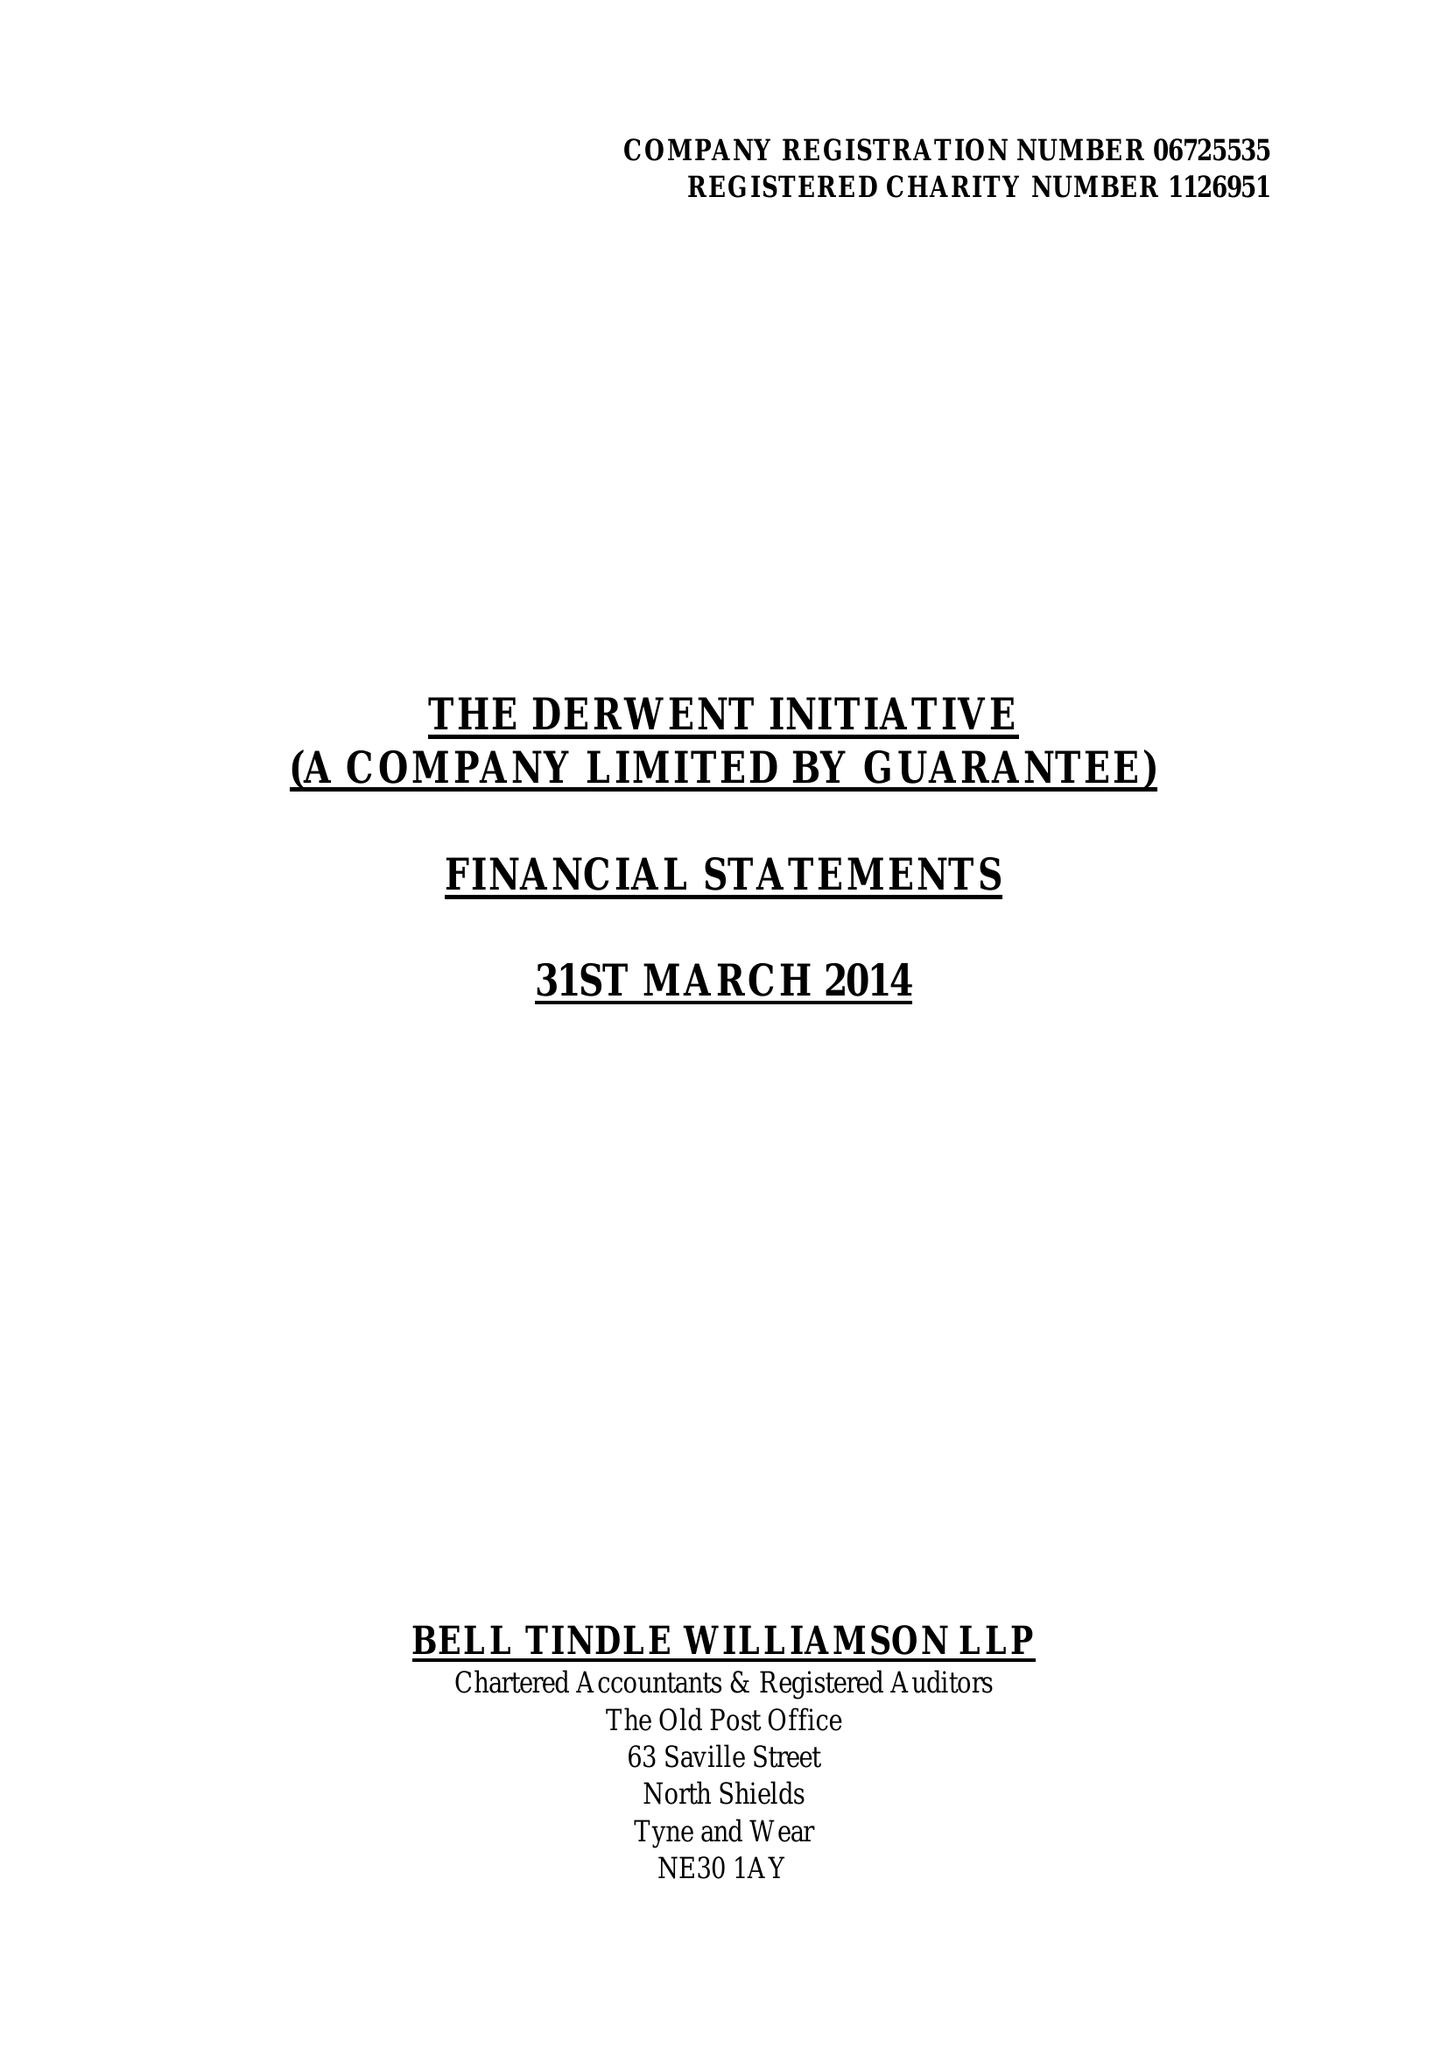What is the value for the charity_number?
Answer the question using a single word or phrase. 1126951 